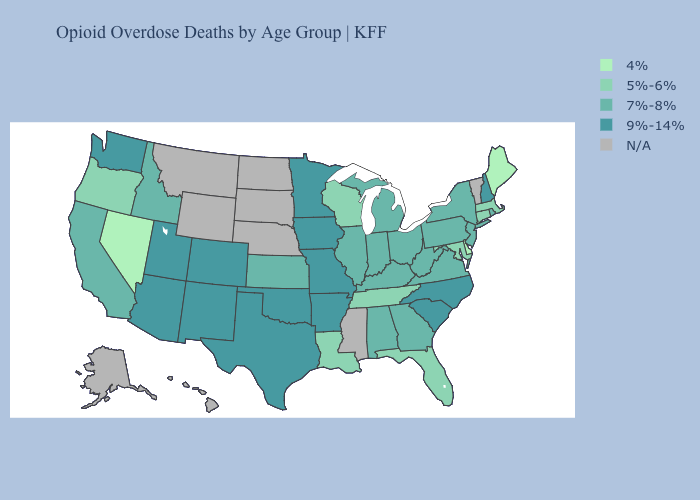Is the legend a continuous bar?
Concise answer only. No. Does the first symbol in the legend represent the smallest category?
Give a very brief answer. Yes. Among the states that border New Mexico , which have the lowest value?
Give a very brief answer. Arizona, Colorado, Oklahoma, Texas, Utah. Which states hav the highest value in the West?
Keep it brief. Arizona, Colorado, New Mexico, Utah, Washington. What is the value of New Hampshire?
Give a very brief answer. 9%-14%. Name the states that have a value in the range 5%-6%?
Concise answer only. Connecticut, Florida, Louisiana, Maryland, Massachusetts, Oregon, Tennessee, Wisconsin. Is the legend a continuous bar?
Give a very brief answer. No. Name the states that have a value in the range 9%-14%?
Be succinct. Arizona, Arkansas, Colorado, Iowa, Minnesota, Missouri, New Hampshire, New Mexico, North Carolina, Oklahoma, South Carolina, Texas, Utah, Washington. What is the value of California?
Give a very brief answer. 7%-8%. Among the states that border Idaho , which have the highest value?
Write a very short answer. Utah, Washington. Does Maine have the lowest value in the USA?
Keep it brief. Yes. What is the value of Florida?
Be succinct. 5%-6%. Is the legend a continuous bar?
Short answer required. No. Name the states that have a value in the range 4%?
Give a very brief answer. Delaware, Maine, Nevada. 